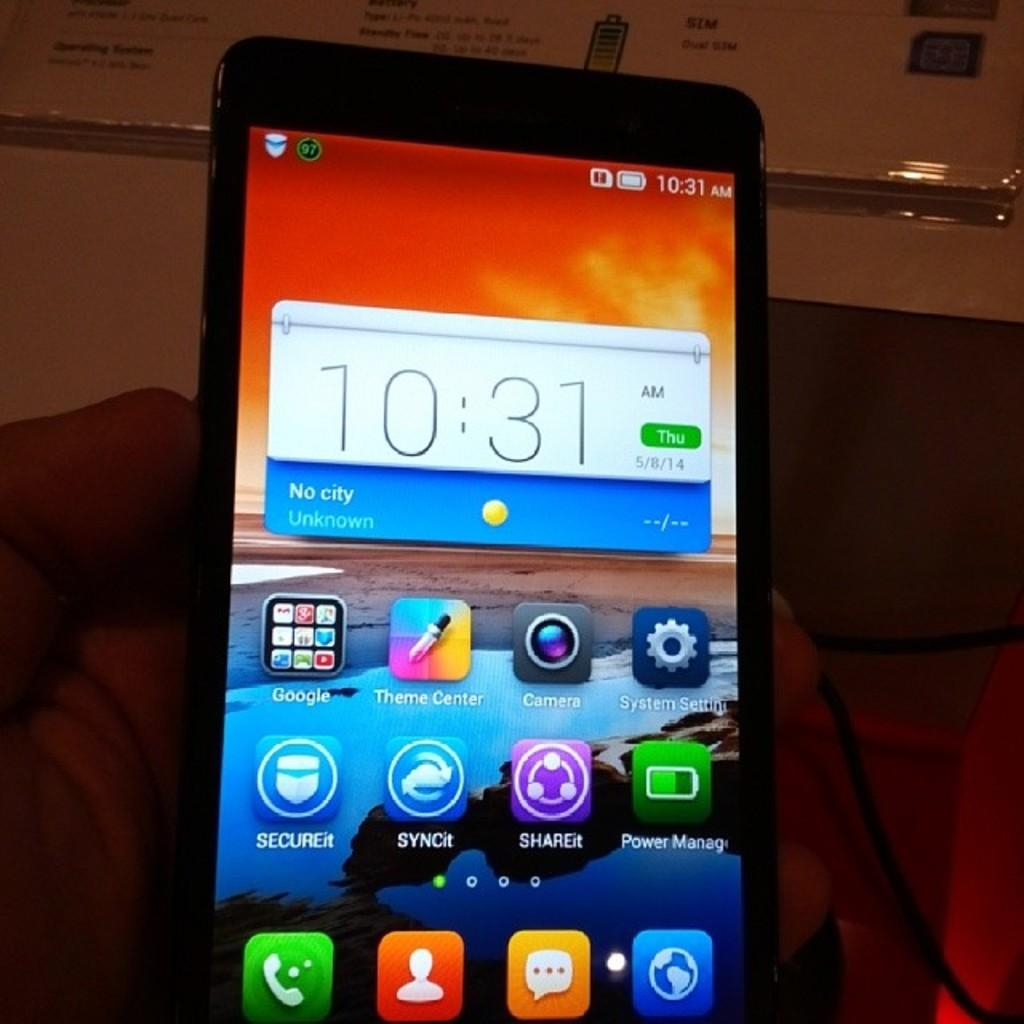<image>
Provide a brief description of the given image. cellphone showing 10:31 am with date of thurs 5/8/14 